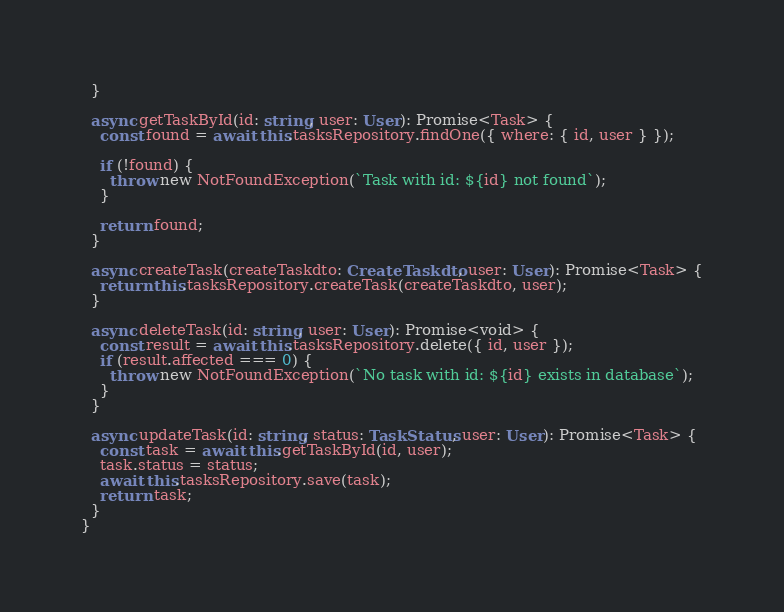Convert code to text. <code><loc_0><loc_0><loc_500><loc_500><_TypeScript_>  }

  async getTaskById(id: string, user: User): Promise<Task> {
    const found = await this.tasksRepository.findOne({ where: { id, user } });

    if (!found) {
      throw new NotFoundException(`Task with id: ${id} not found`);
    }

    return found;
  }

  async createTask(createTaskdto: CreateTaskdto, user: User): Promise<Task> {
    return this.tasksRepository.createTask(createTaskdto, user);
  }

  async deleteTask(id: string, user: User): Promise<void> {
    const result = await this.tasksRepository.delete({ id, user });
    if (result.affected === 0) {
      throw new NotFoundException(`No task with id: ${id} exists in database`);
    }
  }

  async updateTask(id: string, status: TaskStatus, user: User): Promise<Task> {
    const task = await this.getTaskById(id, user);
    task.status = status;
    await this.tasksRepository.save(task);
    return task;
  }
}
</code> 